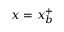Convert formula to latex. <formula><loc_0><loc_0><loc_500><loc_500>x = x _ { b } ^ { + }</formula> 